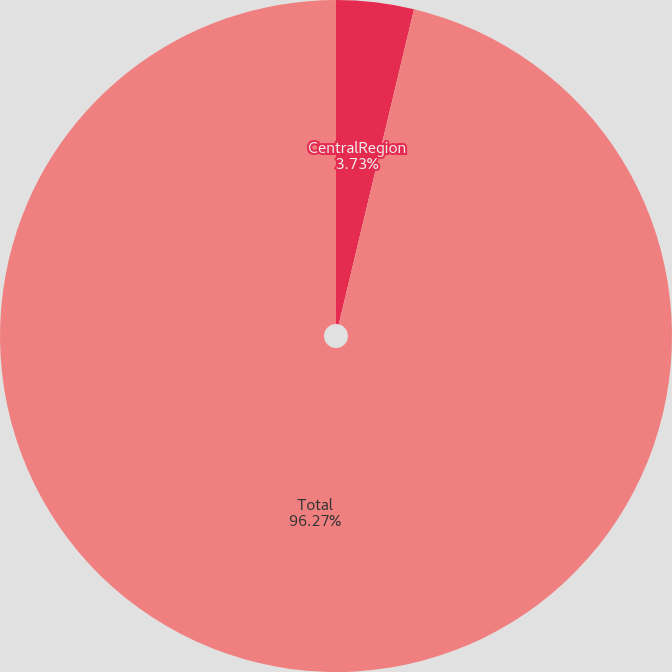Convert chart. <chart><loc_0><loc_0><loc_500><loc_500><pie_chart><fcel>CentralRegion<fcel>Total<nl><fcel>3.73%<fcel>96.27%<nl></chart> 